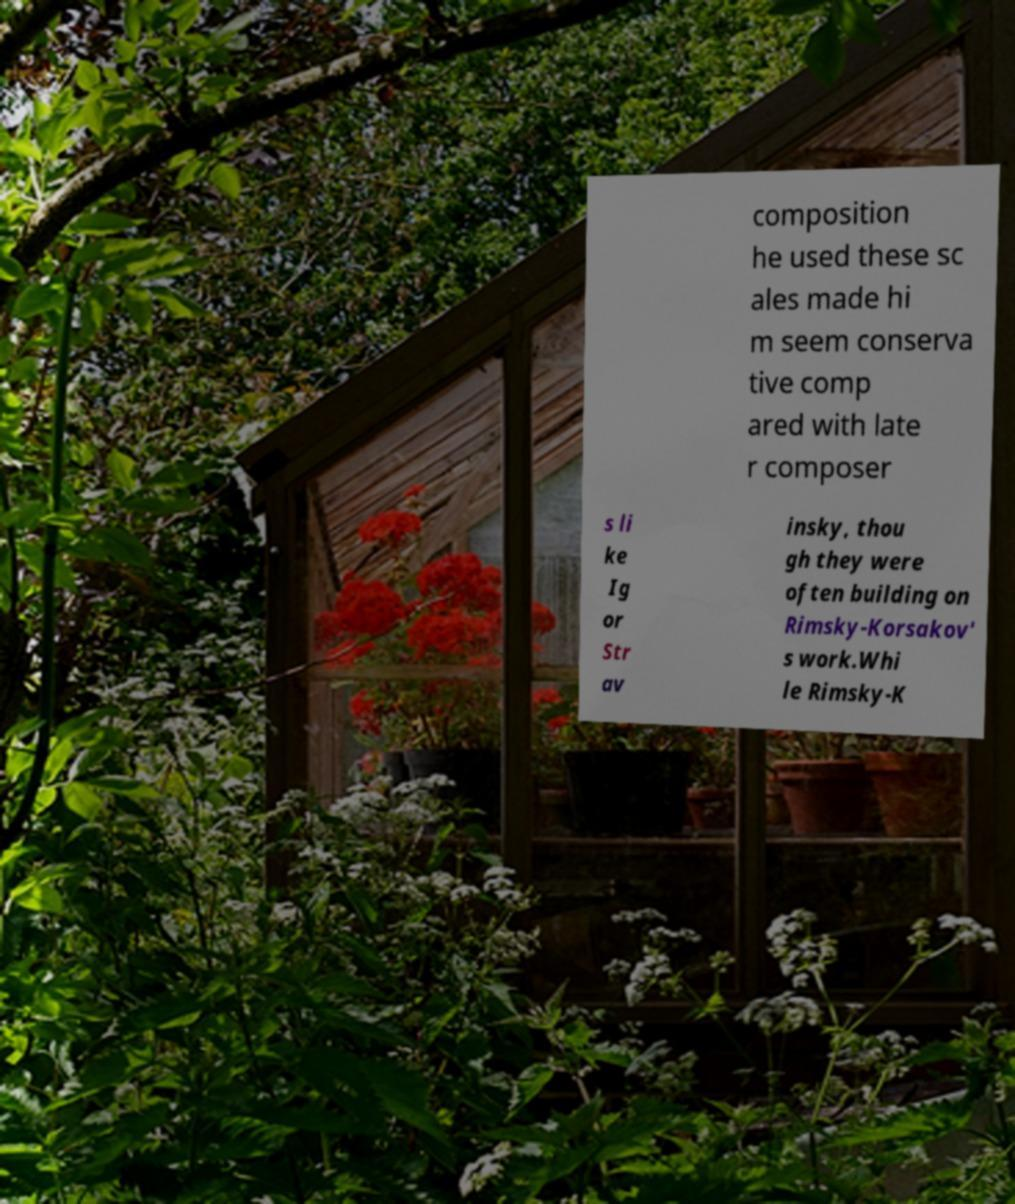For documentation purposes, I need the text within this image transcribed. Could you provide that? composition he used these sc ales made hi m seem conserva tive comp ared with late r composer s li ke Ig or Str av insky, thou gh they were often building on Rimsky-Korsakov' s work.Whi le Rimsky-K 